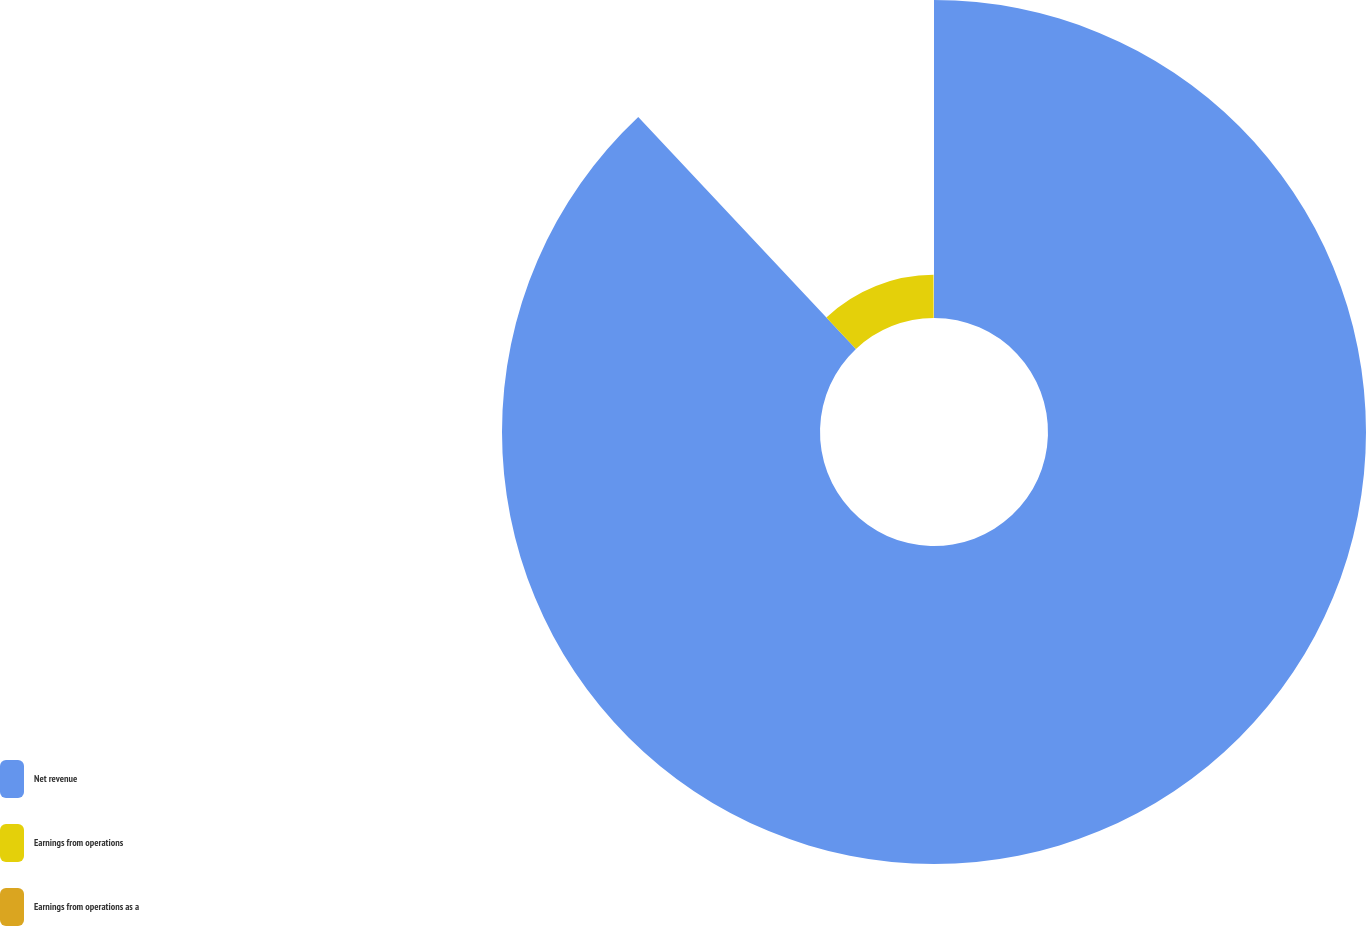<chart> <loc_0><loc_0><loc_500><loc_500><pie_chart><fcel>Net revenue<fcel>Earnings from operations<fcel>Earnings from operations as a<nl><fcel>87.99%<fcel>11.95%<fcel>0.05%<nl></chart> 